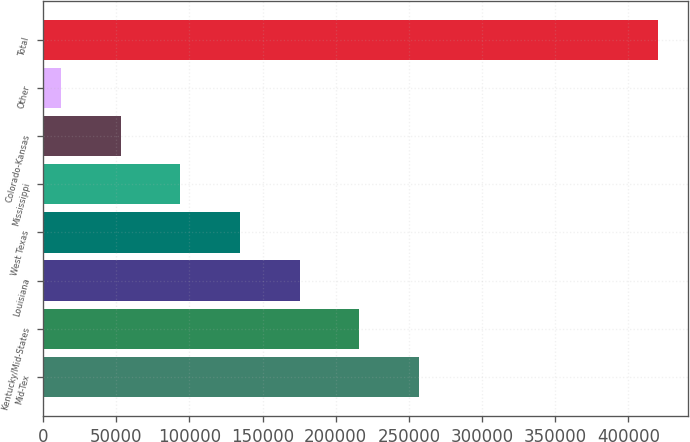Convert chart. <chart><loc_0><loc_0><loc_500><loc_500><bar_chart><fcel>Mid-Tex<fcel>Kentucky/Mid-States<fcel>Louisiana<fcel>West Texas<fcel>Mississippi<fcel>Colorado-Kansas<fcel>Other<fcel>Total<nl><fcel>256939<fcel>216136<fcel>175333<fcel>134531<fcel>93728.2<fcel>52925.6<fcel>12123<fcel>420149<nl></chart> 